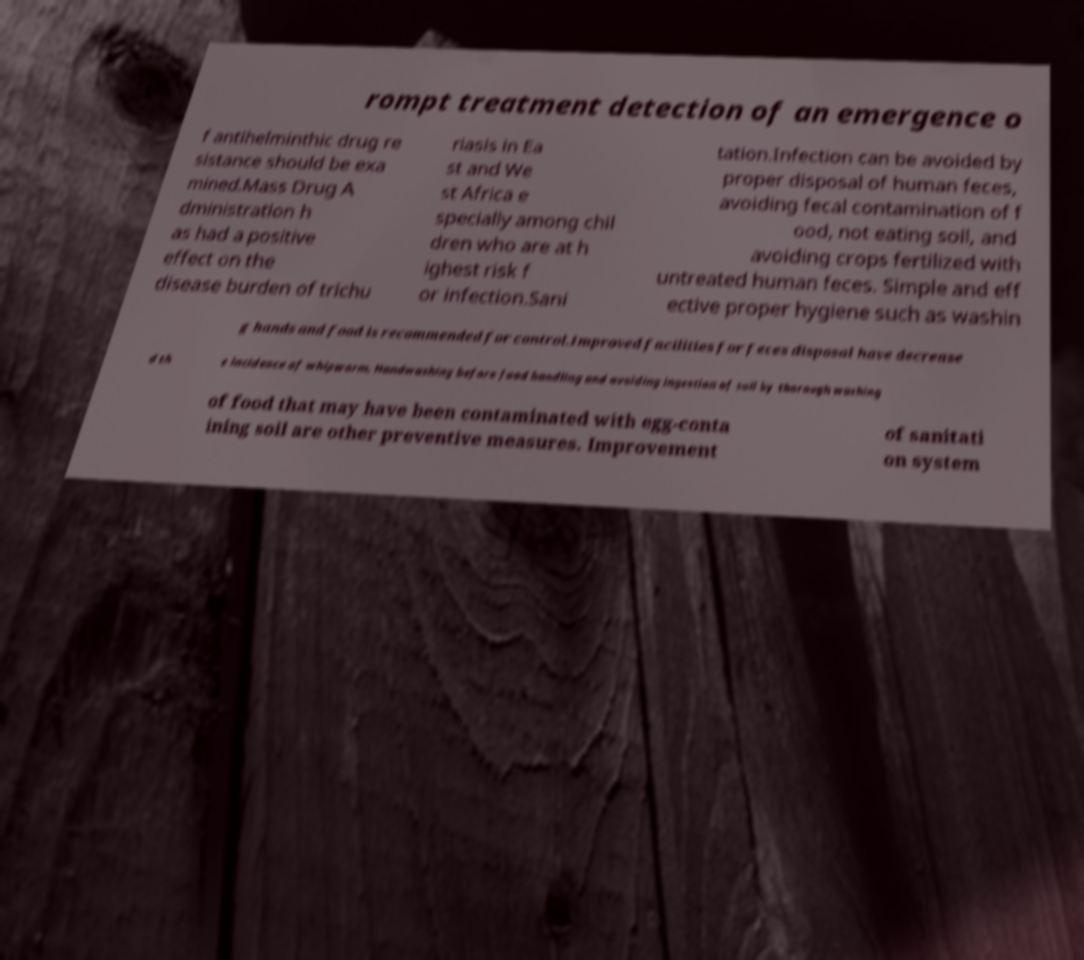Can you accurately transcribe the text from the provided image for me? rompt treatment detection of an emergence o f antihelminthic drug re sistance should be exa mined.Mass Drug A dministration h as had a positive effect on the disease burden of trichu riasis in Ea st and We st Africa e specially among chil dren who are at h ighest risk f or infection.Sani tation.Infection can be avoided by proper disposal of human feces, avoiding fecal contamination of f ood, not eating soil, and avoiding crops fertilized with untreated human feces. Simple and eff ective proper hygiene such as washin g hands and food is recommended for control.Improved facilities for feces disposal have decrease d th e incidence of whipworm. Handwashing before food handling and avoiding ingestion of soil by thorough washing of food that may have been contaminated with egg-conta ining soil are other preventive measures. Improvement of sanitati on system 